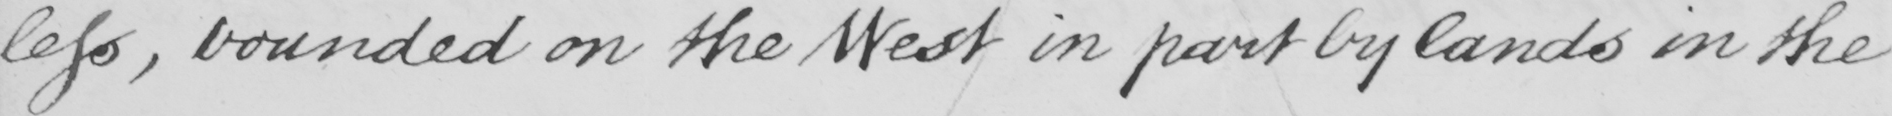What text is written in this handwritten line? less , bounded on the West in part by lands in the 